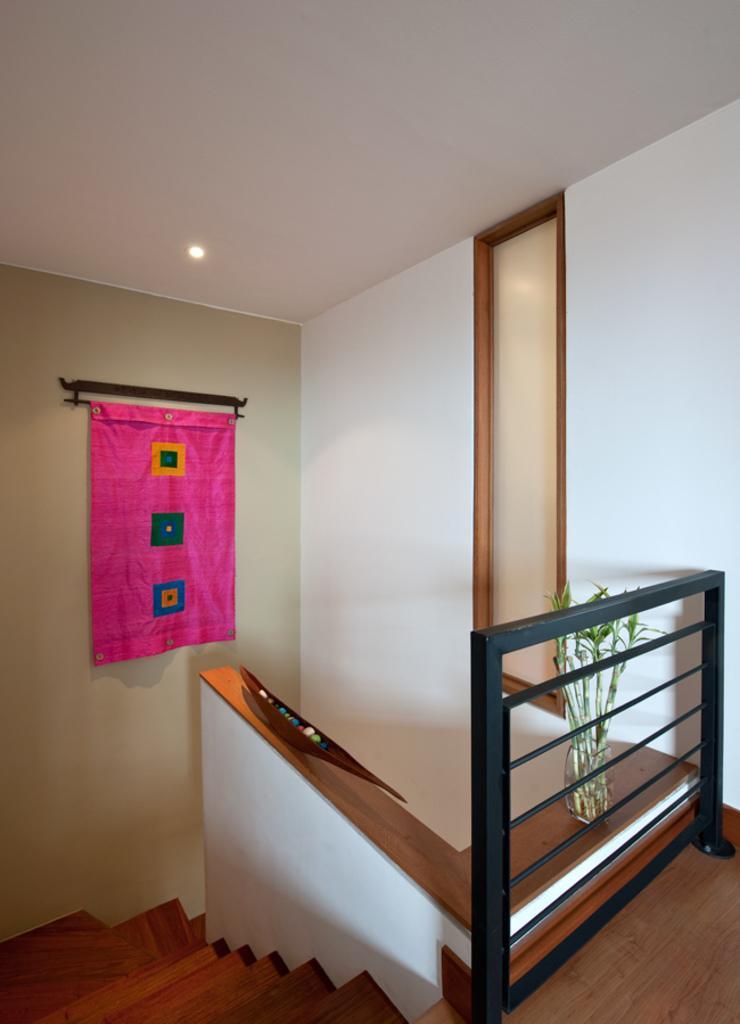In one or two sentences, can you explain what this image depicts? There are stairs in a house and above the stairs there is an iron railing and in front of that there is a plant kept in a glass, in the background there is a wall and there is a small curtain kept to the wall. 